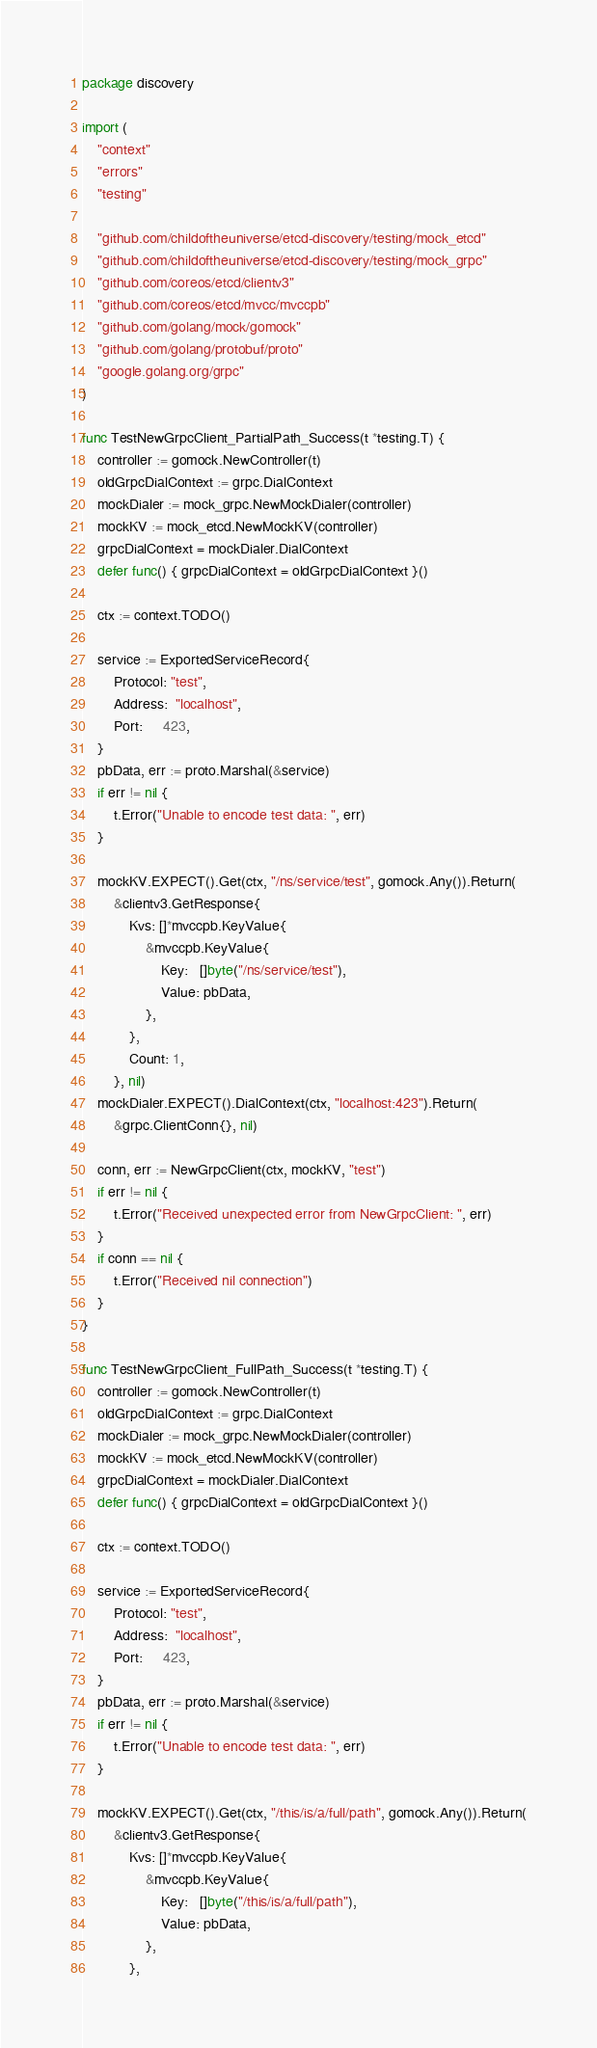<code> <loc_0><loc_0><loc_500><loc_500><_Go_>package discovery

import (
	"context"
	"errors"
	"testing"

	"github.com/childoftheuniverse/etcd-discovery/testing/mock_etcd"
	"github.com/childoftheuniverse/etcd-discovery/testing/mock_grpc"
	"github.com/coreos/etcd/clientv3"
	"github.com/coreos/etcd/mvcc/mvccpb"
	"github.com/golang/mock/gomock"
	"github.com/golang/protobuf/proto"
	"google.golang.org/grpc"
)

func TestNewGrpcClient_PartialPath_Success(t *testing.T) {
	controller := gomock.NewController(t)
	oldGrpcDialContext := grpc.DialContext
	mockDialer := mock_grpc.NewMockDialer(controller)
	mockKV := mock_etcd.NewMockKV(controller)
	grpcDialContext = mockDialer.DialContext
	defer func() { grpcDialContext = oldGrpcDialContext }()

	ctx := context.TODO()

	service := ExportedServiceRecord{
		Protocol: "test",
		Address:  "localhost",
		Port:     423,
	}
	pbData, err := proto.Marshal(&service)
	if err != nil {
		t.Error("Unable to encode test data: ", err)
	}

	mockKV.EXPECT().Get(ctx, "/ns/service/test", gomock.Any()).Return(
		&clientv3.GetResponse{
			Kvs: []*mvccpb.KeyValue{
				&mvccpb.KeyValue{
					Key:   []byte("/ns/service/test"),
					Value: pbData,
				},
			},
			Count: 1,
		}, nil)
	mockDialer.EXPECT().DialContext(ctx, "localhost:423").Return(
		&grpc.ClientConn{}, nil)

	conn, err := NewGrpcClient(ctx, mockKV, "test")
	if err != nil {
		t.Error("Received unexpected error from NewGrpcClient: ", err)
	}
	if conn == nil {
		t.Error("Received nil connection")
	}
}

func TestNewGrpcClient_FullPath_Success(t *testing.T) {
	controller := gomock.NewController(t)
	oldGrpcDialContext := grpc.DialContext
	mockDialer := mock_grpc.NewMockDialer(controller)
	mockKV := mock_etcd.NewMockKV(controller)
	grpcDialContext = mockDialer.DialContext
	defer func() { grpcDialContext = oldGrpcDialContext }()

	ctx := context.TODO()

	service := ExportedServiceRecord{
		Protocol: "test",
		Address:  "localhost",
		Port:     423,
	}
	pbData, err := proto.Marshal(&service)
	if err != nil {
		t.Error("Unable to encode test data: ", err)
	}

	mockKV.EXPECT().Get(ctx, "/this/is/a/full/path", gomock.Any()).Return(
		&clientv3.GetResponse{
			Kvs: []*mvccpb.KeyValue{
				&mvccpb.KeyValue{
					Key:   []byte("/this/is/a/full/path"),
					Value: pbData,
				},
			},</code> 